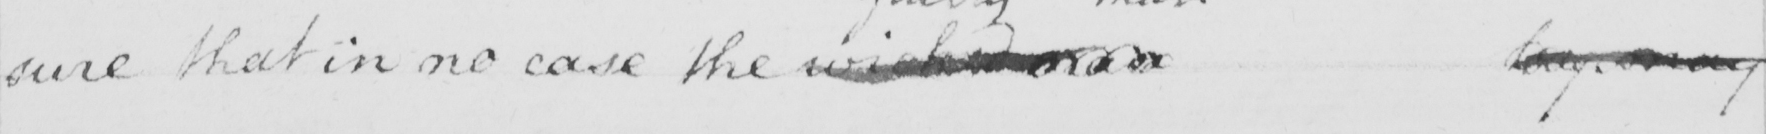Please transcribe the handwritten text in this image. sure that in no case the wicked man try may 